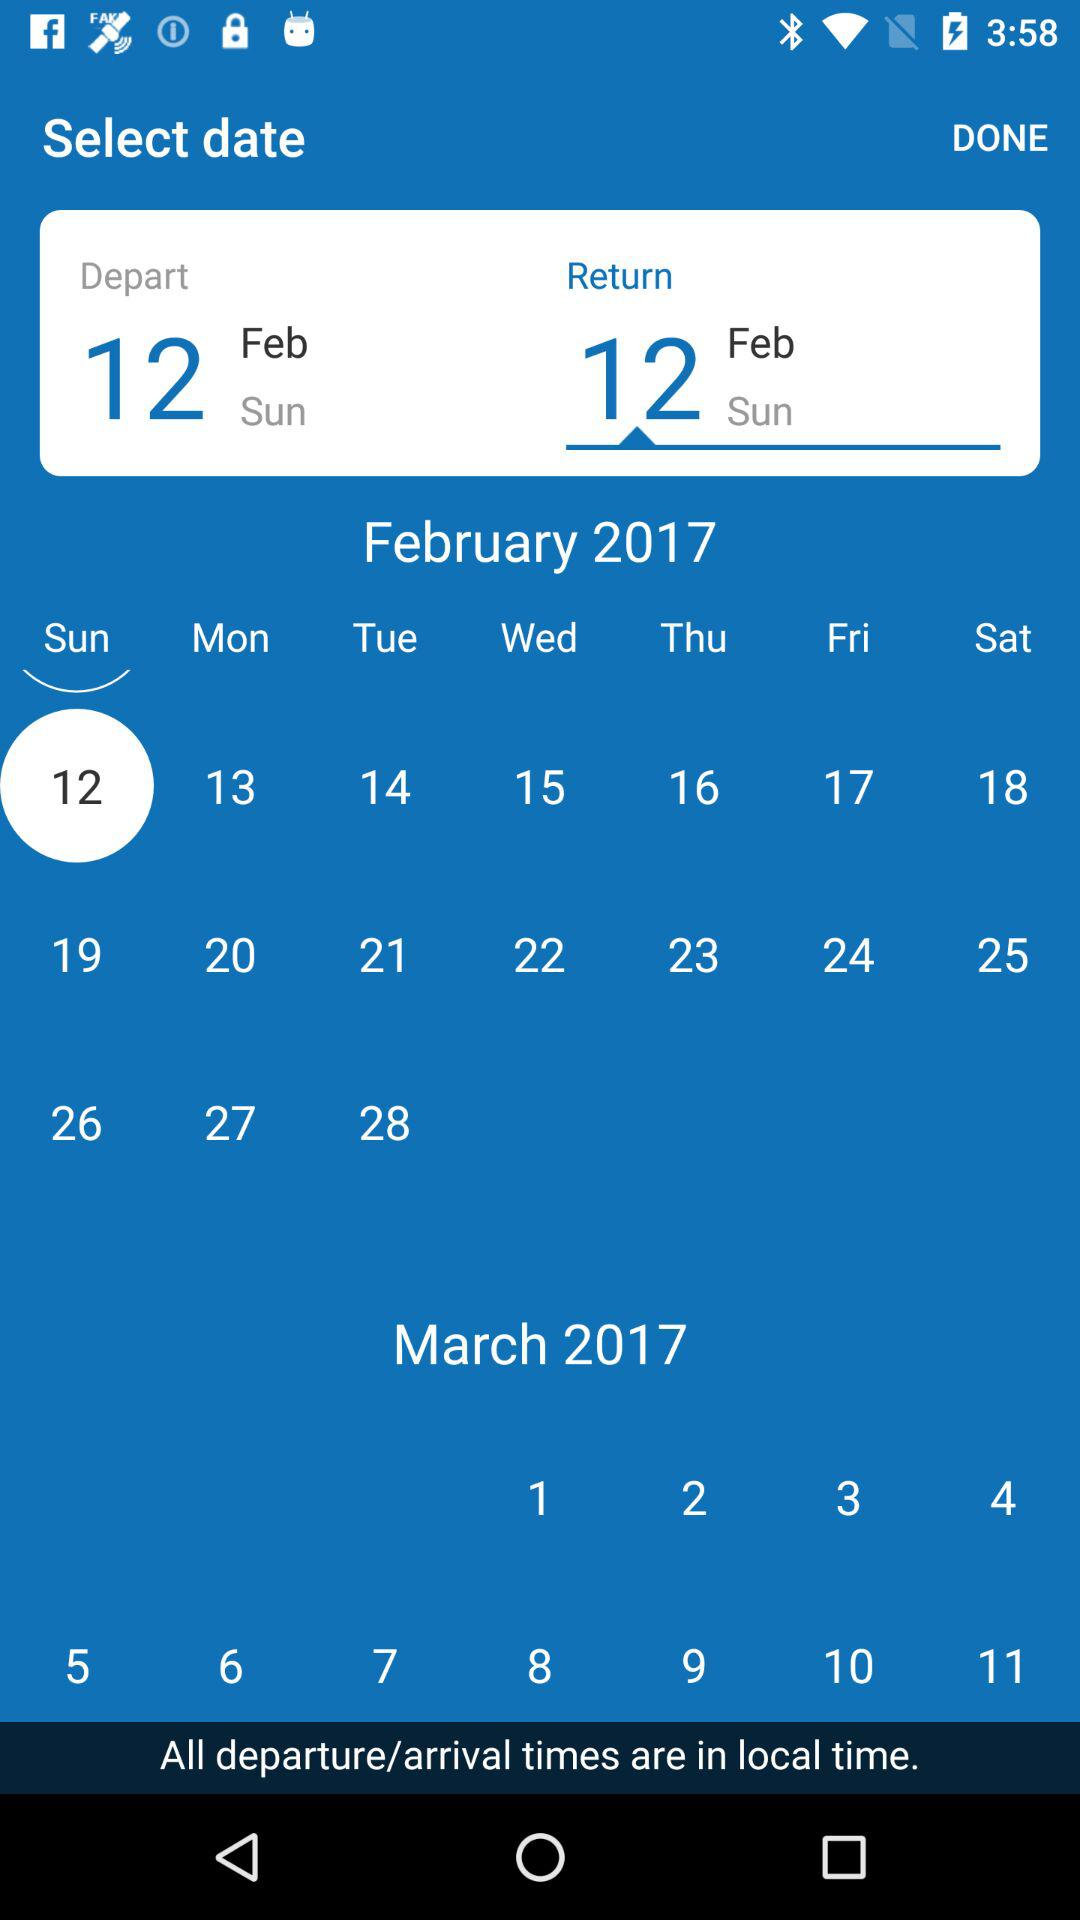What is the return date? The return date is Sunday, February 12, 2017. 